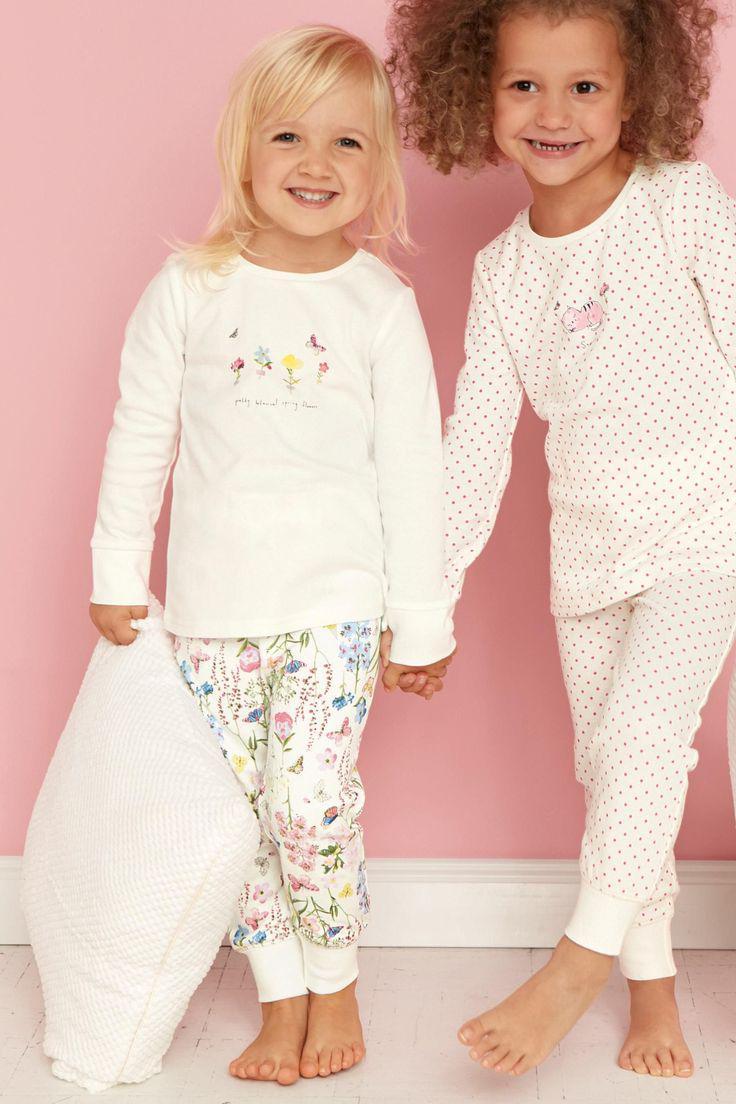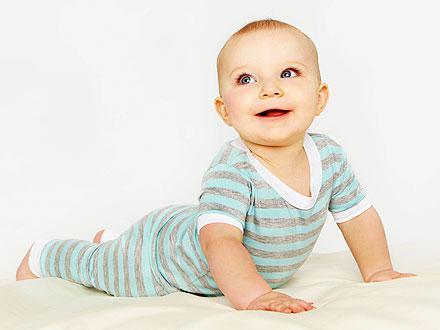The first image is the image on the left, the second image is the image on the right. Given the left and right images, does the statement "There are three children" hold true? Answer yes or no. Yes. The first image is the image on the left, the second image is the image on the right. Examine the images to the left and right. Is the description "There is atleast one photo with two girls holding hands" accurate? Answer yes or no. Yes. 